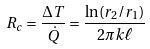<formula> <loc_0><loc_0><loc_500><loc_500>R _ { c } = { \frac { \Delta T } { \dot { Q } } } = { \frac { \ln ( r _ { 2 } / r _ { 1 } ) } { 2 \pi k \ell } }</formula> 